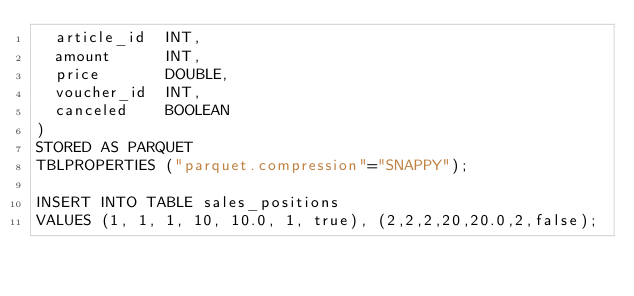Convert code to text. <code><loc_0><loc_0><loc_500><loc_500><_SQL_>  article_id  INT,
  amount      INT,
  price       DOUBLE,
  voucher_id  INT,
  canceled    BOOLEAN
)
STORED AS PARQUET
TBLPROPERTIES ("parquet.compression"="SNAPPY");

INSERT INTO TABLE sales_positions
VALUES (1, 1, 1, 10, 10.0, 1, true), (2,2,2,20,20.0,2,false);
</code> 